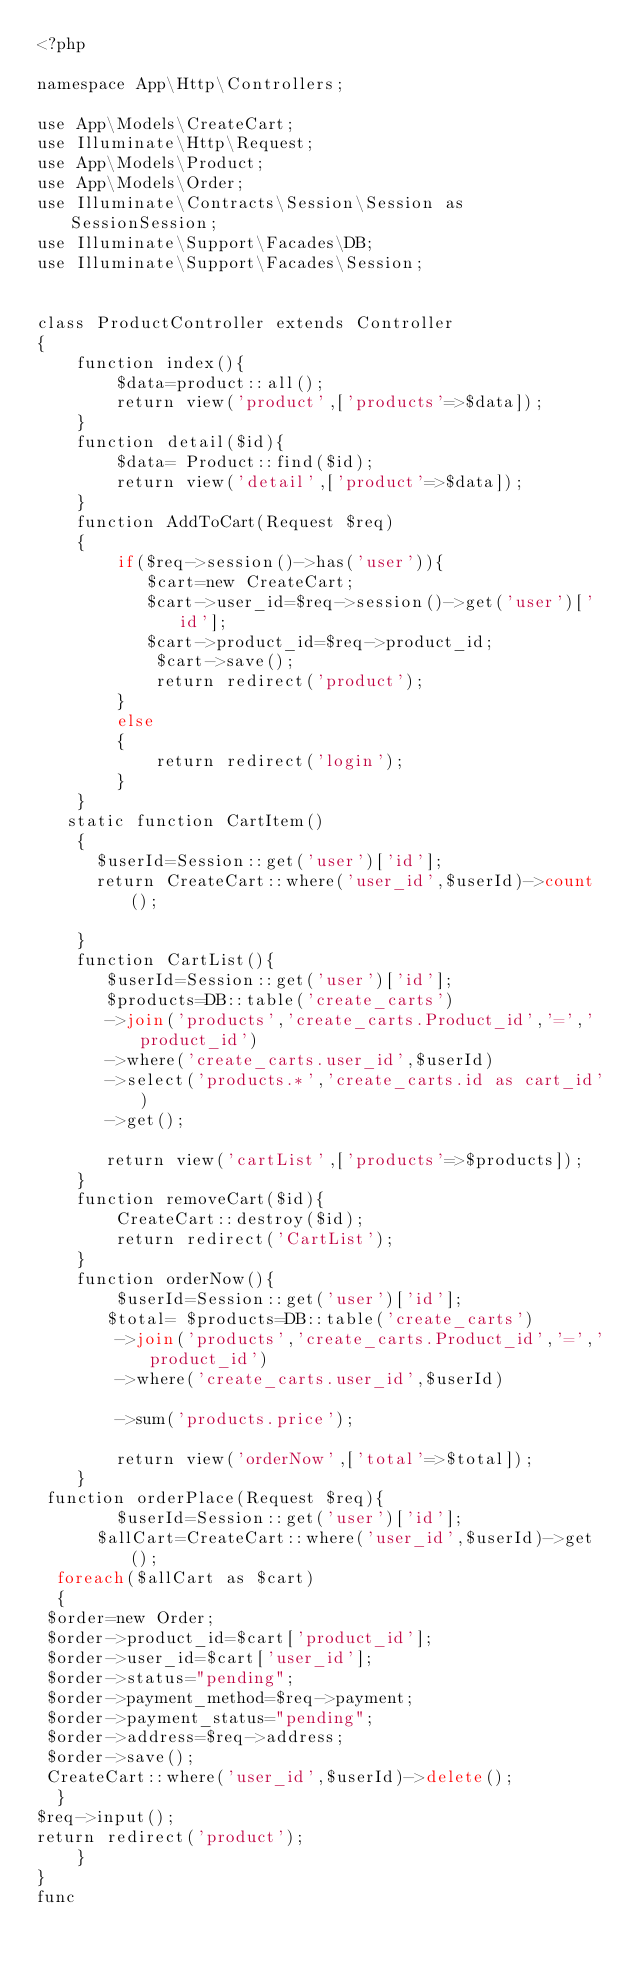Convert code to text. <code><loc_0><loc_0><loc_500><loc_500><_PHP_><?php

namespace App\Http\Controllers;

use App\Models\CreateCart;
use Illuminate\Http\Request;
use App\Models\Product;
use App\Models\Order;
use Illuminate\Contracts\Session\Session as SessionSession;
use Illuminate\Support\Facades\DB;
use Illuminate\Support\Facades\Session;


class ProductController extends Controller
{
    function index(){
        $data=product::all();
        return view('product',['products'=>$data]);
    }
    function detail($id){
        $data= Product::find($id);
        return view('detail',['product'=>$data]);
    }
    function AddToCart(Request $req)
    {
        if($req->session()->has('user')){
           $cart=new CreateCart;
           $cart->user_id=$req->session()->get('user')['id'];
           $cart->product_id=$req->product_id;
            $cart->save();
            return redirect('product');
        }
        else
        {
            return redirect('login');
        }
    }
   static function CartItem()
    {
      $userId=Session::get('user')['id'];
      return CreateCart::where('user_id',$userId)->count();

    }
    function CartList(){
       $userId=Session::get('user')['id'];
       $products=DB::table('create_carts')
       ->join('products','create_carts.Product_id','=','product_id')
       ->where('create_carts.user_id',$userId)
       ->select('products.*','create_carts.id as cart_id')
       ->get();

       return view('cartList',['products'=>$products]);
    }
    function removeCart($id){
        CreateCart::destroy($id);
        return redirect('CartList');
    }
    function orderNow(){
        $userId=Session::get('user')['id'];
       $total= $products=DB::table('create_carts')
        ->join('products','create_carts.Product_id','=','product_id')
        ->where('create_carts.user_id',$userId)

        ->sum('products.price');

        return view('orderNow',['total'=>$total]);
    }
 function orderPlace(Request $req){
        $userId=Session::get('user')['id'];
      $allCart=CreateCart::where('user_id',$userId)->get();
  foreach($allCart as $cart)
  {
 $order=new Order;
 $order->product_id=$cart['product_id'];
 $order->user_id=$cart['user_id'];
 $order->status="pending";
 $order->payment_method=$req->payment;
 $order->payment_status="pending";
 $order->address=$req->address;
 $order->save();
 CreateCart::where('user_id',$userId)->delete();
  }
$req->input();
return redirect('product');
    }
}
func
</code> 